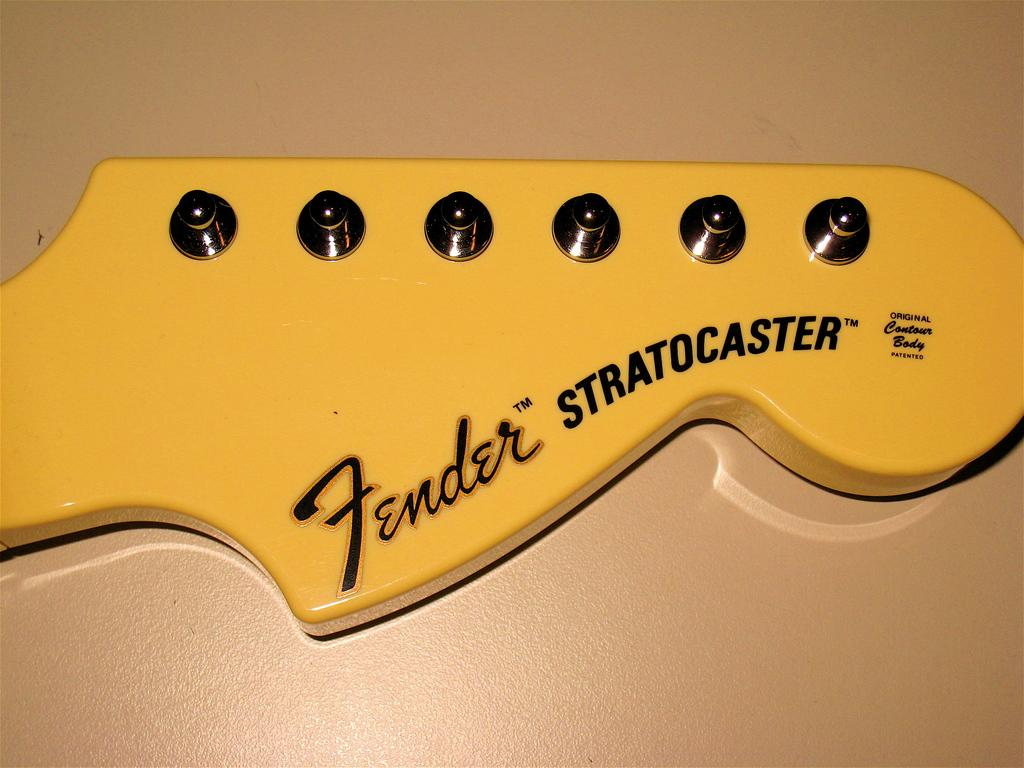What type of musical instrument is in the image? There is a yellow color guitar in the image. What feature does the guitar have for adjusting the pitch of the strings? The guitar has tuners. Are there any words or designs on the guitar? Yes, there are texts on the guitar. On what surface is the guitar placed? The guitar is on a surface. What color is the background of the image? The background of the image is cream in color. How many cows are visible in the image? There are no cows present in the image. What type of war is being depicted in the image? There is no war depicted in the image; it features a guitar. 